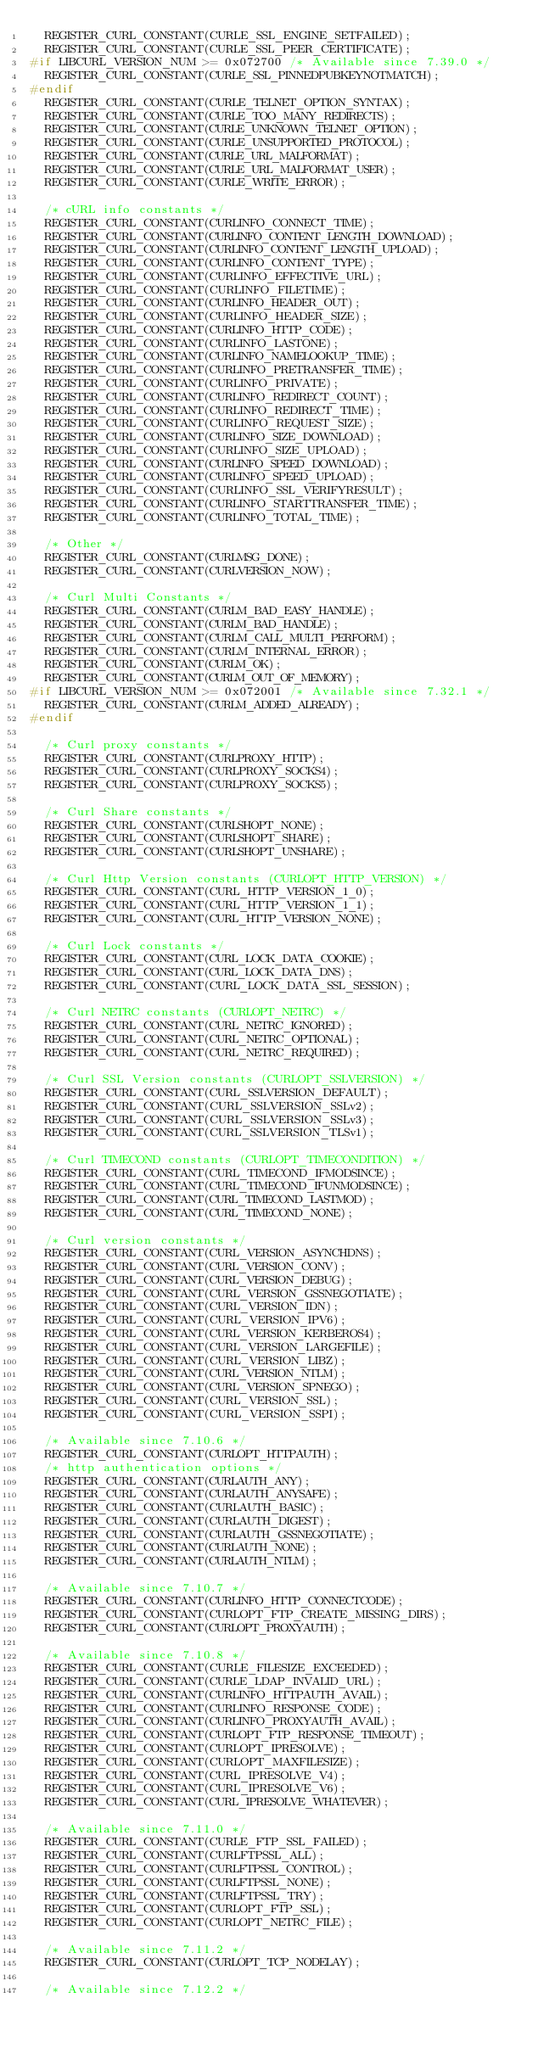<code> <loc_0><loc_0><loc_500><loc_500><_C_>	REGISTER_CURL_CONSTANT(CURLE_SSL_ENGINE_SETFAILED);
	REGISTER_CURL_CONSTANT(CURLE_SSL_PEER_CERTIFICATE);
#if LIBCURL_VERSION_NUM >= 0x072700 /* Available since 7.39.0 */
	REGISTER_CURL_CONSTANT(CURLE_SSL_PINNEDPUBKEYNOTMATCH);
#endif
	REGISTER_CURL_CONSTANT(CURLE_TELNET_OPTION_SYNTAX);
	REGISTER_CURL_CONSTANT(CURLE_TOO_MANY_REDIRECTS);
	REGISTER_CURL_CONSTANT(CURLE_UNKNOWN_TELNET_OPTION);
	REGISTER_CURL_CONSTANT(CURLE_UNSUPPORTED_PROTOCOL);
	REGISTER_CURL_CONSTANT(CURLE_URL_MALFORMAT);
	REGISTER_CURL_CONSTANT(CURLE_URL_MALFORMAT_USER);
	REGISTER_CURL_CONSTANT(CURLE_WRITE_ERROR);

	/* cURL info constants */
	REGISTER_CURL_CONSTANT(CURLINFO_CONNECT_TIME);
	REGISTER_CURL_CONSTANT(CURLINFO_CONTENT_LENGTH_DOWNLOAD);
	REGISTER_CURL_CONSTANT(CURLINFO_CONTENT_LENGTH_UPLOAD);
	REGISTER_CURL_CONSTANT(CURLINFO_CONTENT_TYPE);
	REGISTER_CURL_CONSTANT(CURLINFO_EFFECTIVE_URL);
	REGISTER_CURL_CONSTANT(CURLINFO_FILETIME);
	REGISTER_CURL_CONSTANT(CURLINFO_HEADER_OUT);
	REGISTER_CURL_CONSTANT(CURLINFO_HEADER_SIZE);
	REGISTER_CURL_CONSTANT(CURLINFO_HTTP_CODE);
	REGISTER_CURL_CONSTANT(CURLINFO_LASTONE);
	REGISTER_CURL_CONSTANT(CURLINFO_NAMELOOKUP_TIME);
	REGISTER_CURL_CONSTANT(CURLINFO_PRETRANSFER_TIME);
	REGISTER_CURL_CONSTANT(CURLINFO_PRIVATE);
	REGISTER_CURL_CONSTANT(CURLINFO_REDIRECT_COUNT);
	REGISTER_CURL_CONSTANT(CURLINFO_REDIRECT_TIME);
	REGISTER_CURL_CONSTANT(CURLINFO_REQUEST_SIZE);
	REGISTER_CURL_CONSTANT(CURLINFO_SIZE_DOWNLOAD);
	REGISTER_CURL_CONSTANT(CURLINFO_SIZE_UPLOAD);
	REGISTER_CURL_CONSTANT(CURLINFO_SPEED_DOWNLOAD);
	REGISTER_CURL_CONSTANT(CURLINFO_SPEED_UPLOAD);
	REGISTER_CURL_CONSTANT(CURLINFO_SSL_VERIFYRESULT);
	REGISTER_CURL_CONSTANT(CURLINFO_STARTTRANSFER_TIME);
	REGISTER_CURL_CONSTANT(CURLINFO_TOTAL_TIME);

	/* Other */
	REGISTER_CURL_CONSTANT(CURLMSG_DONE);
	REGISTER_CURL_CONSTANT(CURLVERSION_NOW);

	/* Curl Multi Constants */
	REGISTER_CURL_CONSTANT(CURLM_BAD_EASY_HANDLE);
	REGISTER_CURL_CONSTANT(CURLM_BAD_HANDLE);
	REGISTER_CURL_CONSTANT(CURLM_CALL_MULTI_PERFORM);
	REGISTER_CURL_CONSTANT(CURLM_INTERNAL_ERROR);
	REGISTER_CURL_CONSTANT(CURLM_OK);
	REGISTER_CURL_CONSTANT(CURLM_OUT_OF_MEMORY);
#if LIBCURL_VERSION_NUM >= 0x072001 /* Available since 7.32.1 */
	REGISTER_CURL_CONSTANT(CURLM_ADDED_ALREADY);
#endif

	/* Curl proxy constants */
	REGISTER_CURL_CONSTANT(CURLPROXY_HTTP);
	REGISTER_CURL_CONSTANT(CURLPROXY_SOCKS4);
	REGISTER_CURL_CONSTANT(CURLPROXY_SOCKS5);

	/* Curl Share constants */
	REGISTER_CURL_CONSTANT(CURLSHOPT_NONE);
	REGISTER_CURL_CONSTANT(CURLSHOPT_SHARE);
	REGISTER_CURL_CONSTANT(CURLSHOPT_UNSHARE);

	/* Curl Http Version constants (CURLOPT_HTTP_VERSION) */
	REGISTER_CURL_CONSTANT(CURL_HTTP_VERSION_1_0);
	REGISTER_CURL_CONSTANT(CURL_HTTP_VERSION_1_1);
	REGISTER_CURL_CONSTANT(CURL_HTTP_VERSION_NONE);

	/* Curl Lock constants */
	REGISTER_CURL_CONSTANT(CURL_LOCK_DATA_COOKIE);
	REGISTER_CURL_CONSTANT(CURL_LOCK_DATA_DNS);
	REGISTER_CURL_CONSTANT(CURL_LOCK_DATA_SSL_SESSION);

	/* Curl NETRC constants (CURLOPT_NETRC) */
	REGISTER_CURL_CONSTANT(CURL_NETRC_IGNORED);
	REGISTER_CURL_CONSTANT(CURL_NETRC_OPTIONAL);
	REGISTER_CURL_CONSTANT(CURL_NETRC_REQUIRED);

	/* Curl SSL Version constants (CURLOPT_SSLVERSION) */
	REGISTER_CURL_CONSTANT(CURL_SSLVERSION_DEFAULT);
	REGISTER_CURL_CONSTANT(CURL_SSLVERSION_SSLv2);
	REGISTER_CURL_CONSTANT(CURL_SSLVERSION_SSLv3);
	REGISTER_CURL_CONSTANT(CURL_SSLVERSION_TLSv1);

	/* Curl TIMECOND constants (CURLOPT_TIMECONDITION) */
	REGISTER_CURL_CONSTANT(CURL_TIMECOND_IFMODSINCE);
	REGISTER_CURL_CONSTANT(CURL_TIMECOND_IFUNMODSINCE);
	REGISTER_CURL_CONSTANT(CURL_TIMECOND_LASTMOD);
	REGISTER_CURL_CONSTANT(CURL_TIMECOND_NONE);

	/* Curl version constants */
	REGISTER_CURL_CONSTANT(CURL_VERSION_ASYNCHDNS);
	REGISTER_CURL_CONSTANT(CURL_VERSION_CONV);
	REGISTER_CURL_CONSTANT(CURL_VERSION_DEBUG);
	REGISTER_CURL_CONSTANT(CURL_VERSION_GSSNEGOTIATE);
	REGISTER_CURL_CONSTANT(CURL_VERSION_IDN);
	REGISTER_CURL_CONSTANT(CURL_VERSION_IPV6);
	REGISTER_CURL_CONSTANT(CURL_VERSION_KERBEROS4);
	REGISTER_CURL_CONSTANT(CURL_VERSION_LARGEFILE);
	REGISTER_CURL_CONSTANT(CURL_VERSION_LIBZ);
	REGISTER_CURL_CONSTANT(CURL_VERSION_NTLM);
	REGISTER_CURL_CONSTANT(CURL_VERSION_SPNEGO);
	REGISTER_CURL_CONSTANT(CURL_VERSION_SSL);
	REGISTER_CURL_CONSTANT(CURL_VERSION_SSPI);

	/* Available since 7.10.6 */
	REGISTER_CURL_CONSTANT(CURLOPT_HTTPAUTH);
	/* http authentication options */
	REGISTER_CURL_CONSTANT(CURLAUTH_ANY);
	REGISTER_CURL_CONSTANT(CURLAUTH_ANYSAFE);
	REGISTER_CURL_CONSTANT(CURLAUTH_BASIC);
	REGISTER_CURL_CONSTANT(CURLAUTH_DIGEST);
	REGISTER_CURL_CONSTANT(CURLAUTH_GSSNEGOTIATE);
	REGISTER_CURL_CONSTANT(CURLAUTH_NONE);
	REGISTER_CURL_CONSTANT(CURLAUTH_NTLM);

	/* Available since 7.10.7 */
	REGISTER_CURL_CONSTANT(CURLINFO_HTTP_CONNECTCODE);
	REGISTER_CURL_CONSTANT(CURLOPT_FTP_CREATE_MISSING_DIRS);
	REGISTER_CURL_CONSTANT(CURLOPT_PROXYAUTH);

	/* Available since 7.10.8 */
	REGISTER_CURL_CONSTANT(CURLE_FILESIZE_EXCEEDED);
	REGISTER_CURL_CONSTANT(CURLE_LDAP_INVALID_URL);
	REGISTER_CURL_CONSTANT(CURLINFO_HTTPAUTH_AVAIL);
	REGISTER_CURL_CONSTANT(CURLINFO_RESPONSE_CODE);
	REGISTER_CURL_CONSTANT(CURLINFO_PROXYAUTH_AVAIL);
	REGISTER_CURL_CONSTANT(CURLOPT_FTP_RESPONSE_TIMEOUT);
	REGISTER_CURL_CONSTANT(CURLOPT_IPRESOLVE);
	REGISTER_CURL_CONSTANT(CURLOPT_MAXFILESIZE);
	REGISTER_CURL_CONSTANT(CURL_IPRESOLVE_V4);
	REGISTER_CURL_CONSTANT(CURL_IPRESOLVE_V6);
	REGISTER_CURL_CONSTANT(CURL_IPRESOLVE_WHATEVER);

	/* Available since 7.11.0 */
	REGISTER_CURL_CONSTANT(CURLE_FTP_SSL_FAILED);
	REGISTER_CURL_CONSTANT(CURLFTPSSL_ALL);
	REGISTER_CURL_CONSTANT(CURLFTPSSL_CONTROL);
	REGISTER_CURL_CONSTANT(CURLFTPSSL_NONE);
	REGISTER_CURL_CONSTANT(CURLFTPSSL_TRY);
	REGISTER_CURL_CONSTANT(CURLOPT_FTP_SSL);
	REGISTER_CURL_CONSTANT(CURLOPT_NETRC_FILE);

	/* Available since 7.11.2 */
	REGISTER_CURL_CONSTANT(CURLOPT_TCP_NODELAY);

	/* Available since 7.12.2 */</code> 